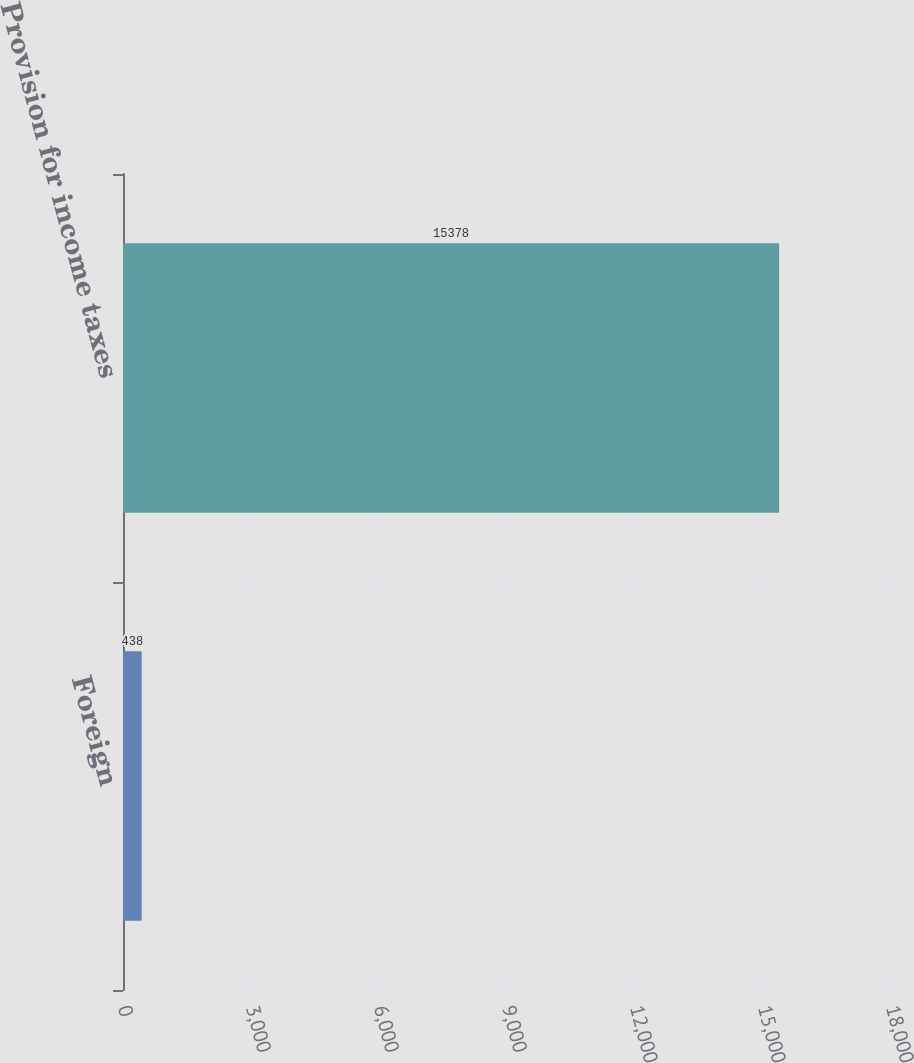Convert chart to OTSL. <chart><loc_0><loc_0><loc_500><loc_500><bar_chart><fcel>Foreign<fcel>Provision for income taxes<nl><fcel>438<fcel>15378<nl></chart> 